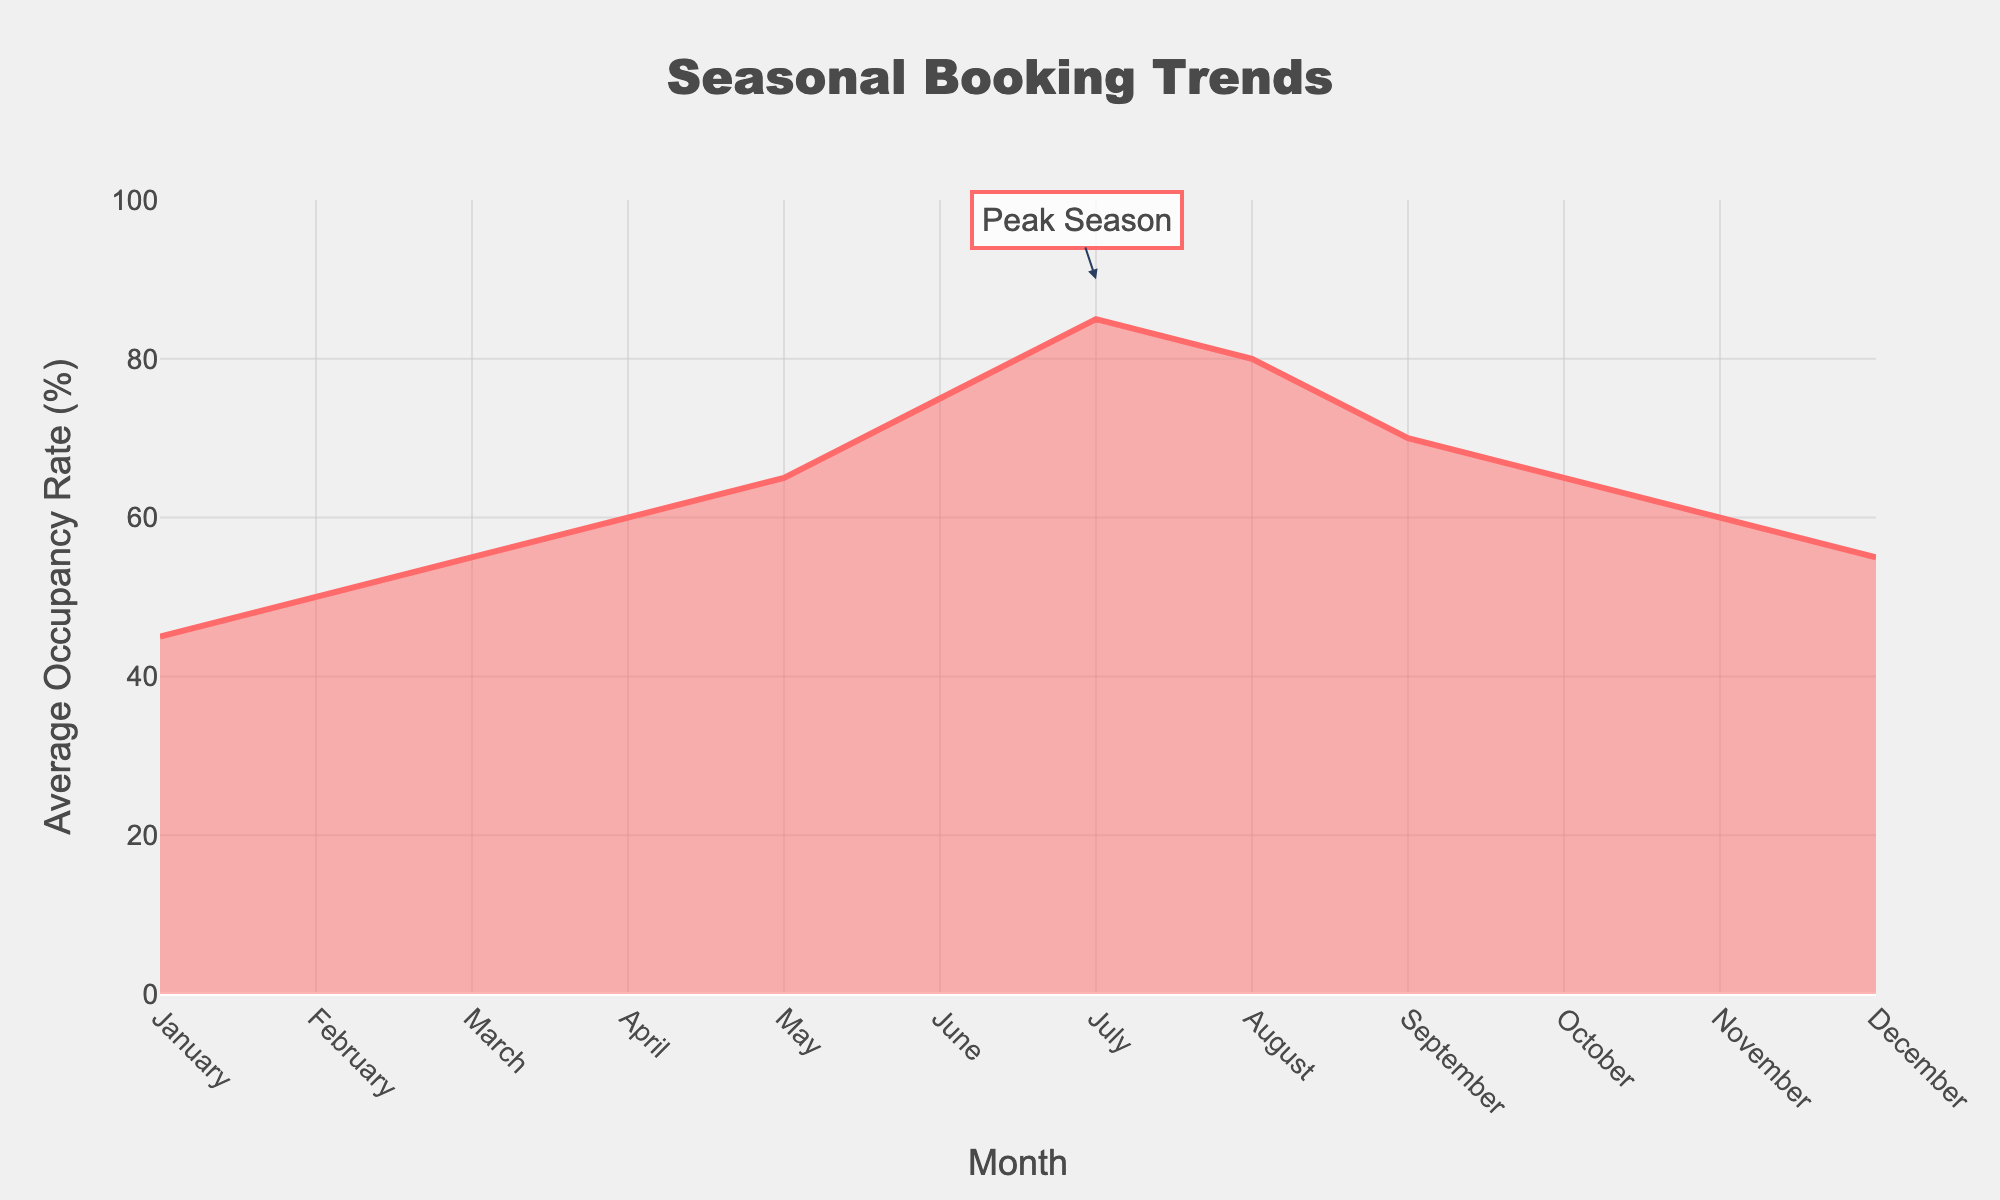What is the title of the figure? The title of the figure is prominently displayed at the top center. It indicates the main subject of the plot.
Answer: Seasonal Booking Trends Which month has the highest average occupancy rate? By looking at the peak point on the y-axis, you can see that the highest average occupancy rate occurs in July.
Answer: July What is the average occupancy rate in January? Locate January on the x-axis, trace the corresponding point on the y-axis, and read the value which is 45%.
Answer: 45% In which months is the average occupancy rate 65%? Find 65% on the y-axis and trace the corresponding months on the x-axis where the line intersects this value, which are May and October.
Answer: May and October How does the occupancy rate change from February to March? Compare the y-axis values for February (50%) and March (55%) to see the increase. The occupancy rate rises by 5 percentage points.
Answer: Increases by 5% Which month has the lowest average occupancy rate? By examining the plot, the lowest point on the y-axis corresponds to January with 45% average occupancy.
Answer: January What is the average occupancy rate during the peak season? The annotation on the plot indicates that July is the peak season with an 85% occupancy rate.
Answer: 85% What is the total difference in occupancy rates from January to December? The occupancy rates for January and December are both 45% and 55%, respectively. The difference between the rates is 10 percentage points.
Answer: 10% During which month does the occupancy rate begin to decrease after reaching its peak? By following the plot, after the peak in July (85%), the occupancy rate starts to decrease in August (80%).
Answer: August 